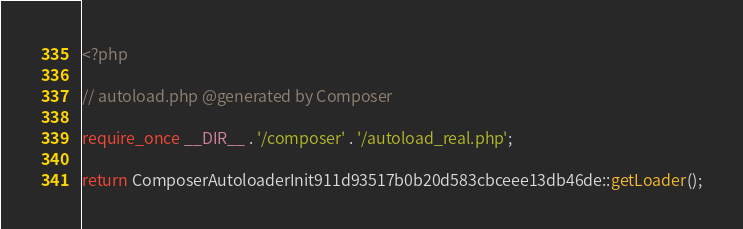<code> <loc_0><loc_0><loc_500><loc_500><_PHP_><?php

// autoload.php @generated by Composer

require_once __DIR__ . '/composer' . '/autoload_real.php';

return ComposerAutoloaderInit911d93517b0b20d583cbceee13db46de::getLoader();
</code> 